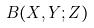<formula> <loc_0><loc_0><loc_500><loc_500>B ( X , Y ; Z )</formula> 